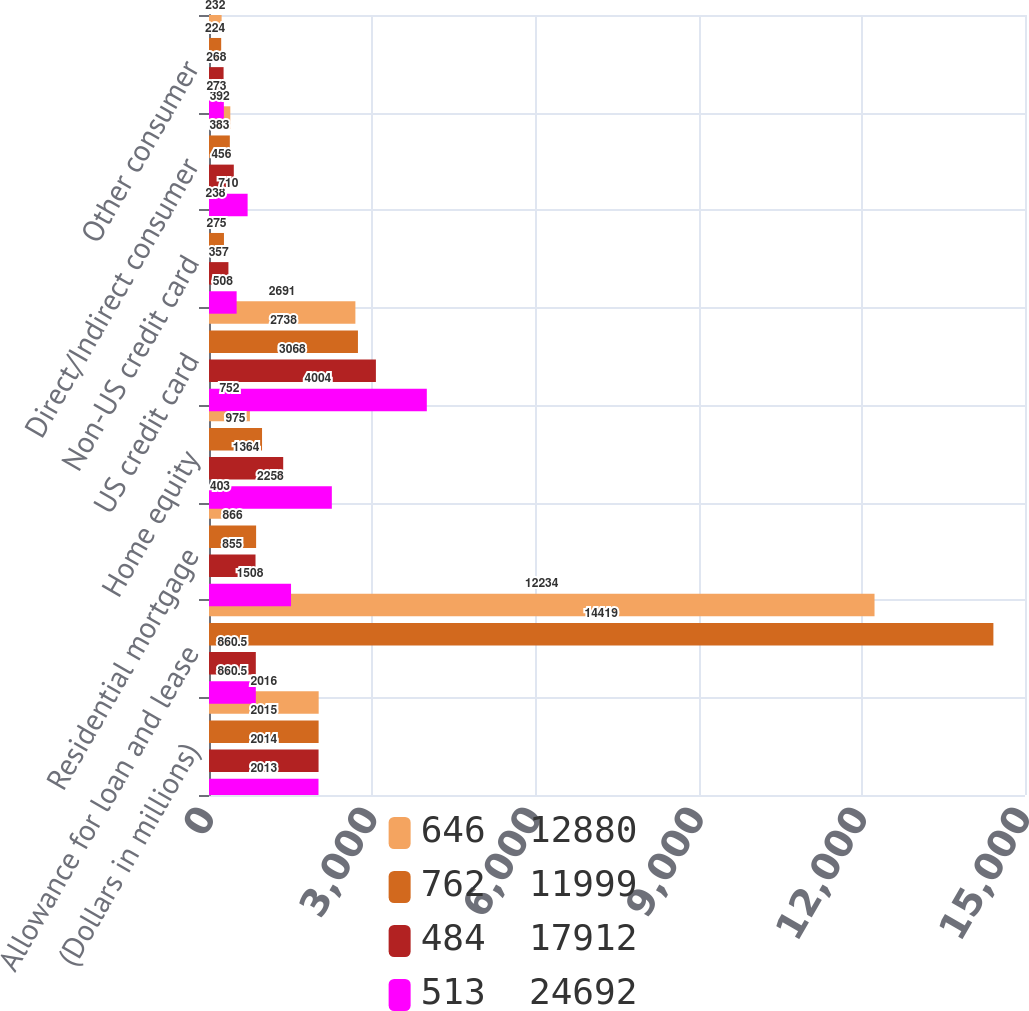Convert chart. <chart><loc_0><loc_0><loc_500><loc_500><stacked_bar_chart><ecel><fcel>(Dollars in millions)<fcel>Allowance for loan and lease<fcel>Residential mortgage<fcel>Home equity<fcel>US credit card<fcel>Non-US credit card<fcel>Direct/Indirect consumer<fcel>Other consumer<nl><fcel>646  12880<fcel>2016<fcel>12234<fcel>403<fcel>752<fcel>2691<fcel>238<fcel>392<fcel>232<nl><fcel>762  11999<fcel>2015<fcel>14419<fcel>866<fcel>975<fcel>2738<fcel>275<fcel>383<fcel>224<nl><fcel>484  17912<fcel>2014<fcel>860.5<fcel>855<fcel>1364<fcel>3068<fcel>357<fcel>456<fcel>268<nl><fcel>513  24692<fcel>2013<fcel>860.5<fcel>1508<fcel>2258<fcel>4004<fcel>508<fcel>710<fcel>273<nl></chart> 